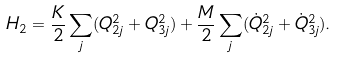Convert formula to latex. <formula><loc_0><loc_0><loc_500><loc_500>H _ { 2 } = \frac { K } { 2 } \sum _ { j } ( Q _ { 2 j } ^ { 2 } + Q _ { 3 j } ^ { 2 } ) + \frac { M } { 2 } \sum _ { j } ( \dot { Q } _ { 2 j } ^ { 2 } + \dot { Q } _ { 3 j } ^ { 2 } ) .</formula> 